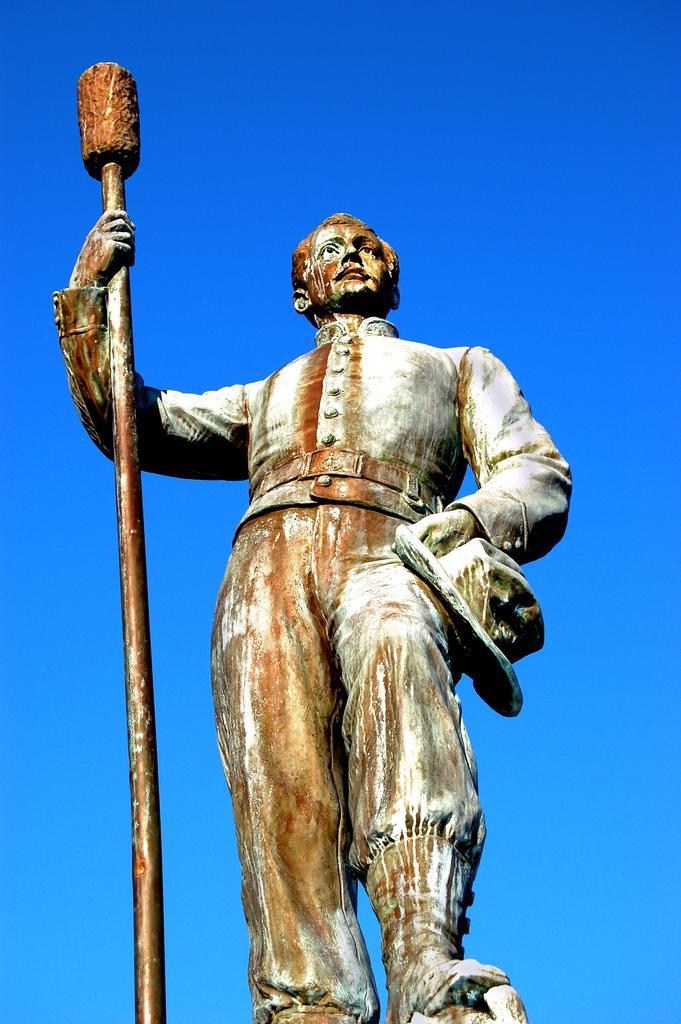Describe this image in one or two sentences. In this image, we can see a statue of a person. In the background, there is the sky. 